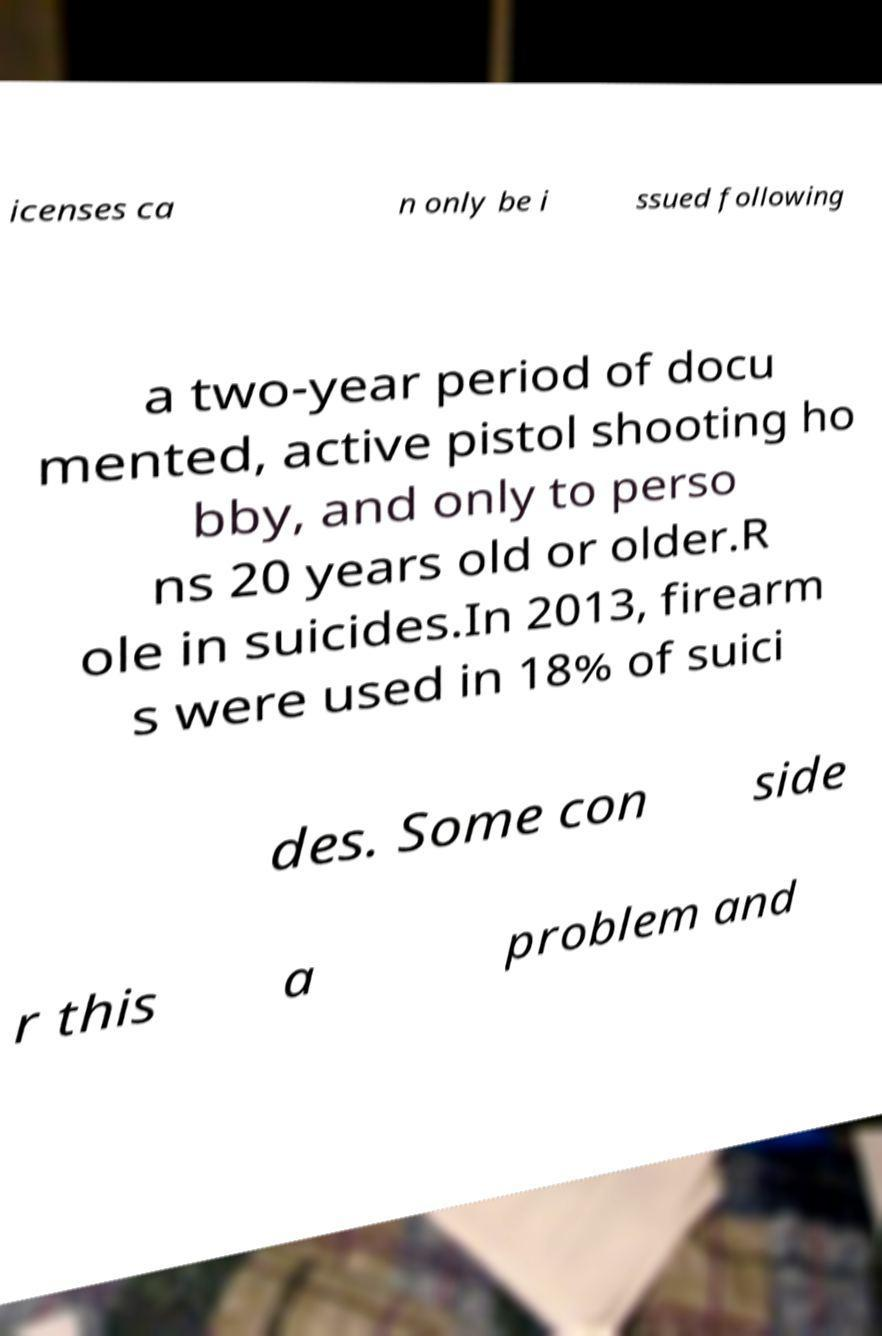For documentation purposes, I need the text within this image transcribed. Could you provide that? icenses ca n only be i ssued following a two-year period of docu mented, active pistol shooting ho bby, and only to perso ns 20 years old or older.R ole in suicides.In 2013, firearm s were used in 18% of suici des. Some con side r this a problem and 